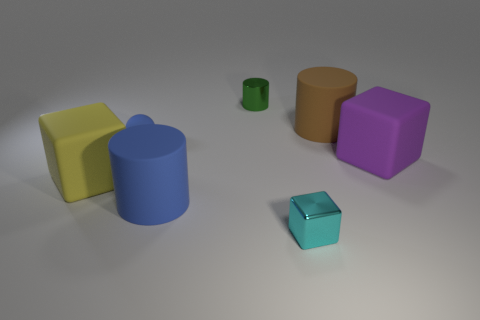The tiny rubber object has what color?
Keep it short and to the point. Blue. How many blue objects have the same shape as the green metallic thing?
Provide a short and direct response. 1. Do the small object that is right of the green metal object and the big cube that is to the left of the cyan shiny cube have the same material?
Provide a short and direct response. No. How big is the rubber block on the left side of the cyan metallic block that is to the right of the yellow rubber block?
Offer a terse response. Large. There is a large blue object that is the same shape as the small green shiny object; what material is it?
Your answer should be compact. Rubber. There is a small green object that is behind the yellow cube; is it the same shape as the large blue rubber object in front of the large brown rubber thing?
Provide a short and direct response. Yes. Are there more large brown cylinders than small purple matte things?
Keep it short and to the point. Yes. How big is the blue cylinder?
Provide a short and direct response. Large. How many other objects are there of the same color as the tiny block?
Your answer should be compact. 0. Is the material of the block to the right of the tiny cyan block the same as the big yellow block?
Your response must be concise. Yes. 